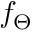Convert formula to latex. <formula><loc_0><loc_0><loc_500><loc_500>f _ { \Theta }</formula> 